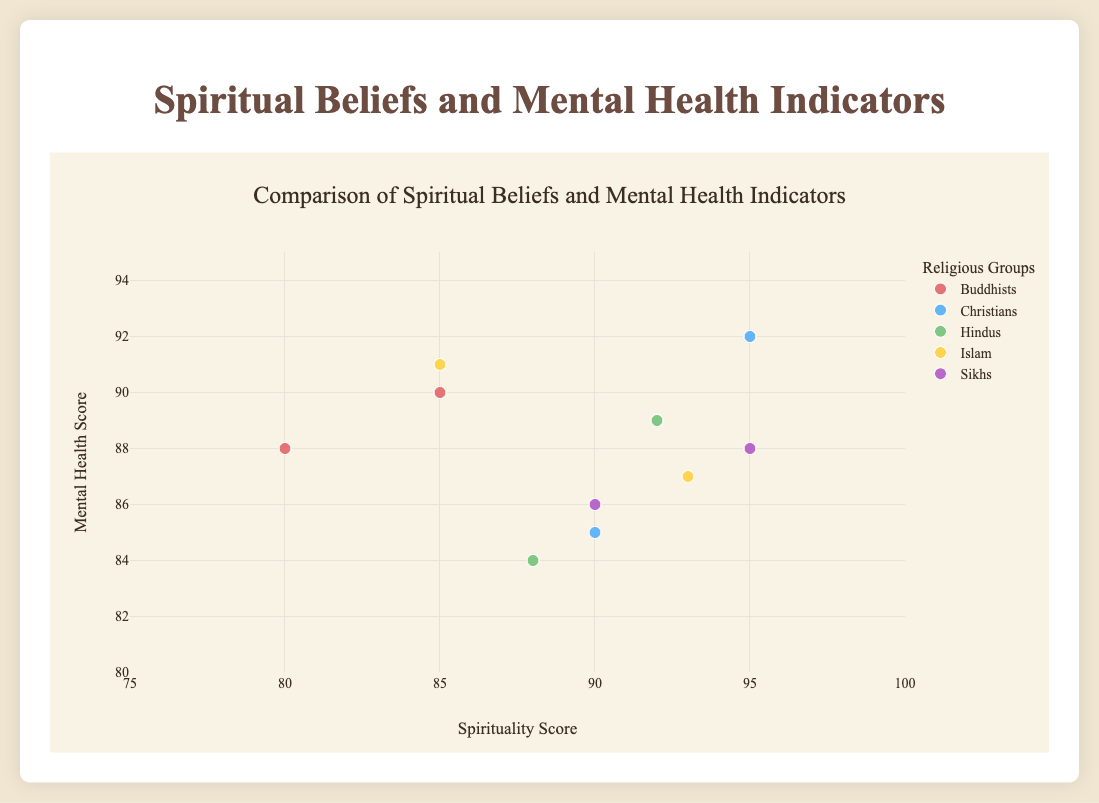What is the title of the figure? The title is written at the top of the figure in a larger font size and is designed to describe the main focus of the figure.
Answer: Comparison of Spiritual Beliefs and Mental Health Indicators What does the x-axis represent? The x-axis represents the data related to spiritual beliefs. The label at the bottom of the x-axis specifies this.
Answer: Spirituality Score Which group has the highest spirituality score? From the scatter plot, we can observe the points of different groups and identify which group has an individual with the highest x-axis value. The Sikhs group, represented by Guru Nanak, has the highest spirituality score of 95.
Answer: Sikhs How many groups are represented in the scatter plot? Each group is distinguished by its unique color. By counting the distinct color markers in the legend, we get the total number of groups present.
Answer: 5 Who in the Buddhists group has the higher mental health score? Locate the markers representing the Buddhists group by their color. Compare the y-axis values (mental health scores) of Thich Nhat Hanh and Pema Chödrön. Thich Nhat Hanh has a mental health score of 90, which is higher than Pema Chödrön’s score of 88.
Answer: Thich Nhat Hanh What is the average spirituality score of the Hindus group? Calculate the average by summing the spirituality scores of individuals in the Hindus group and then dividing by the number of individuals. The scores are 88 for Sri Sri Ravi Shankar and 92 for Sadhguru. (88 + 92) / 2 = 90.
Answer: 90 Which individual has a higher mental health score, Rumi or Malala Yousafzai? Identify the markers for Rumi and Malala Yousafzai in the Islam group. Compare their y-axis values. Rumi has a score of 87, while Malala Yousafzai has a score of 91.
Answer: Malala Yousafzai Who has a higher mental health score, Thomas Merton or Bhai Kanhaiya? Compare the y-axis values associated with the individuals in the Christian and Sikh groups respectively. Thomas Merton has a score of 85, and Bhai Kanhaiya has a score of 86.
Answer: Bhai Kanhaiya Is there any individual with the same spirituality and mental health scores? Check if there are any data points that align perfectly both on the x and y axes. By examining the points, we observe that none perfectly overlap on both axes.
Answer: No Which group shows the greatest variation in mental health scores? Compare the range of y-axis values (mental health scores) within each group. The Christians have scores of 85 and 92, showing a variance of 7.
Answer: Christians 